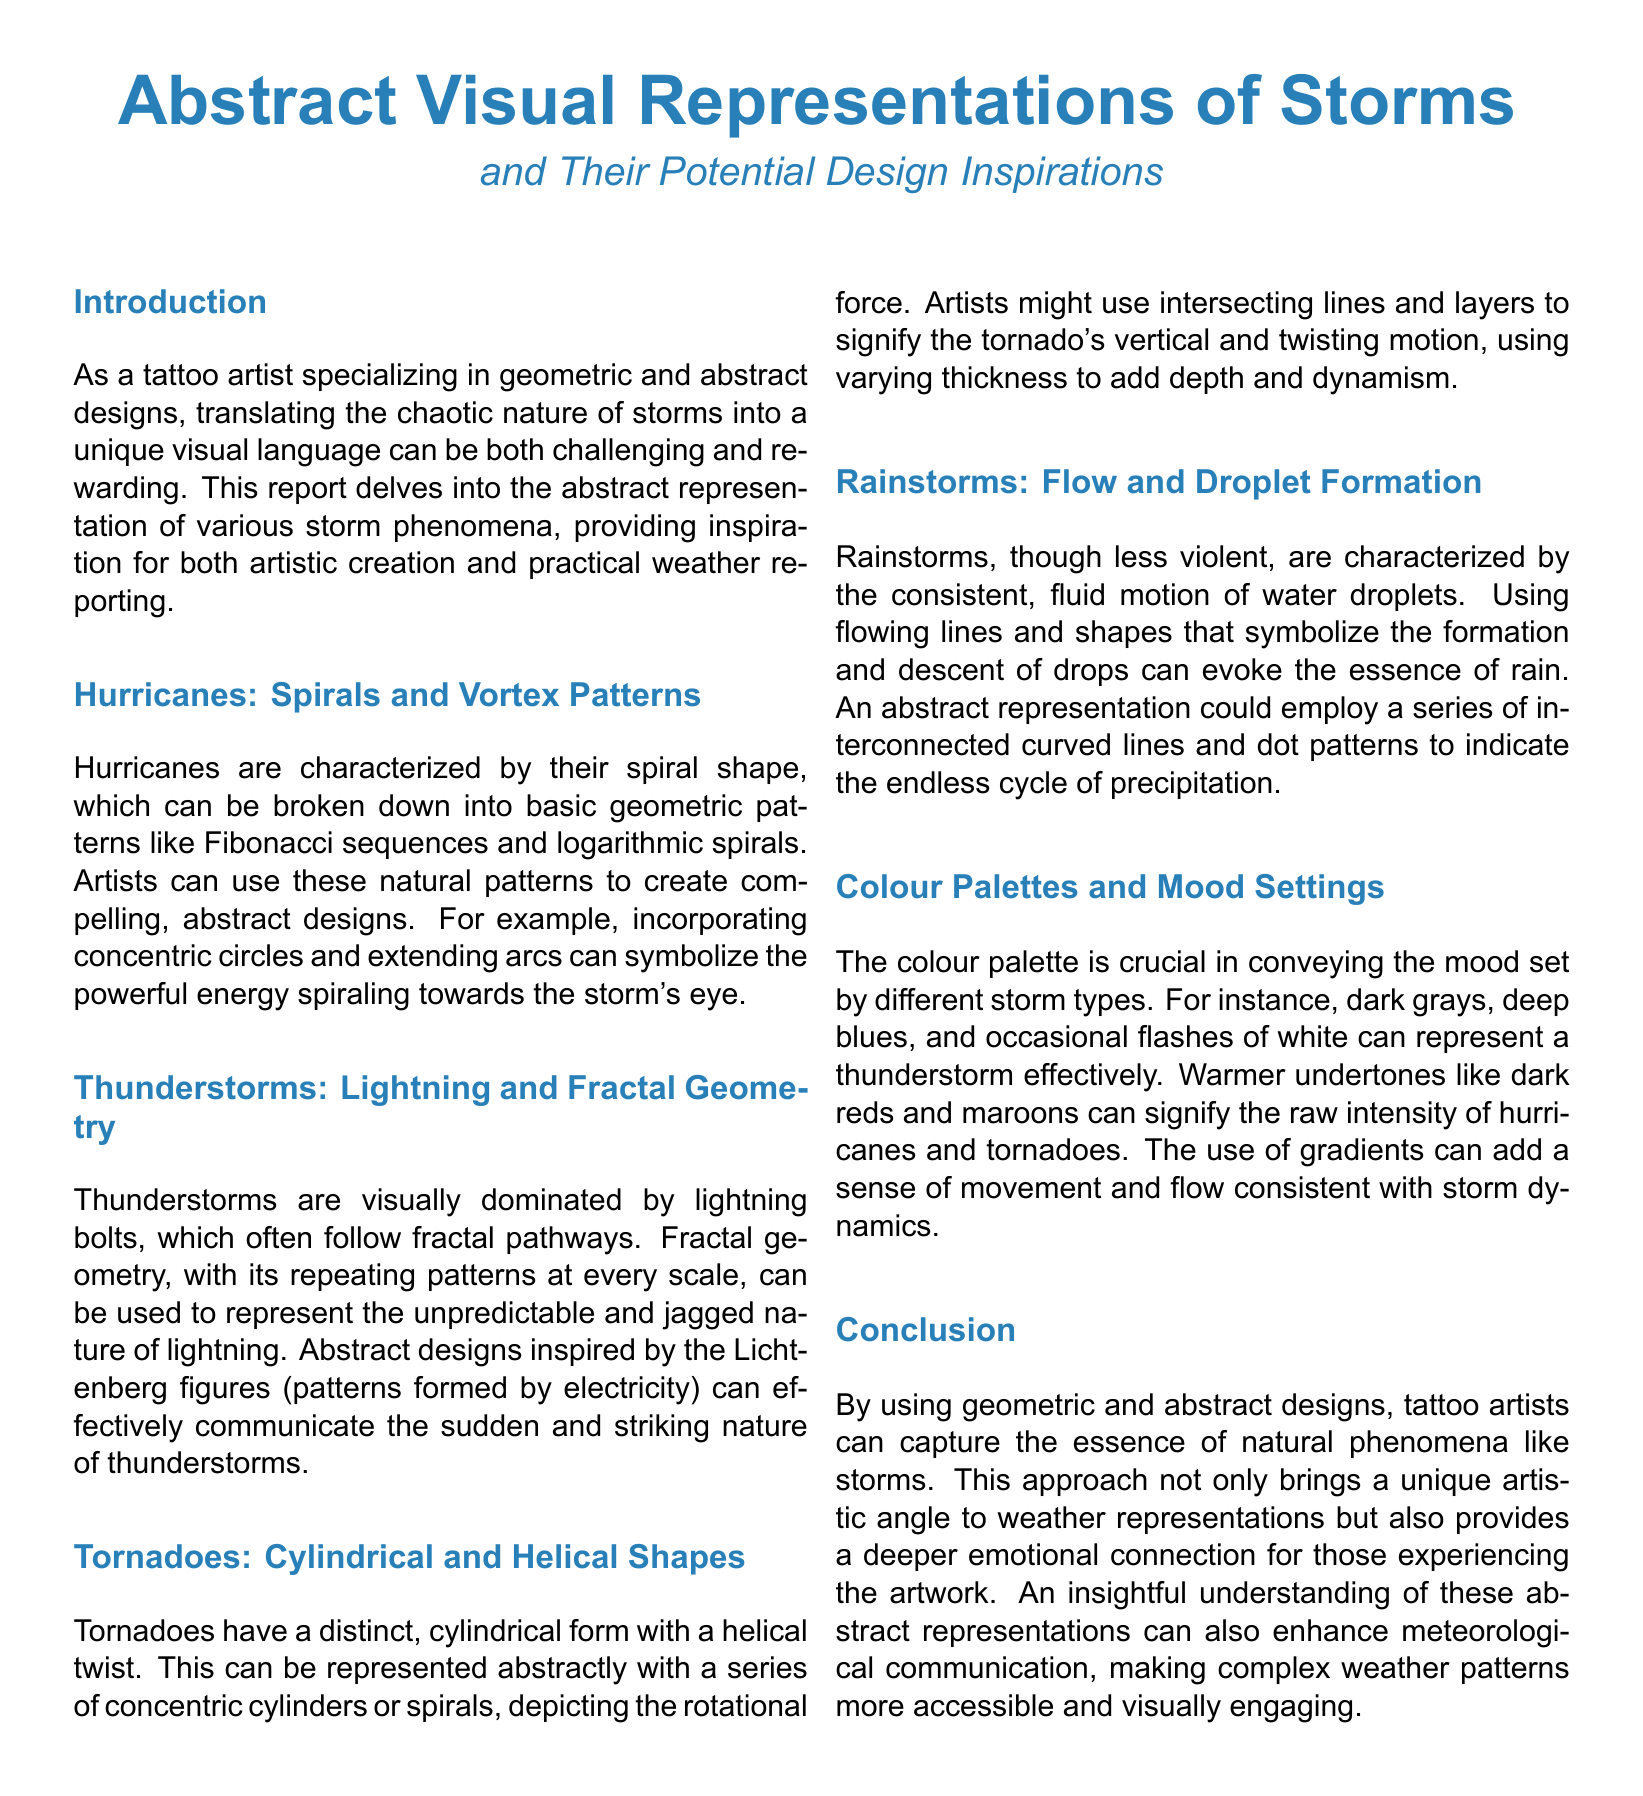What is the main topic of this document? The main topic is the abstract visual representations of storms and their potential design inspirations for tattoo artists.
Answer: Abstract Visual Representations of Storms What color is predominantly associated with thunderstorms? The document describes the mood settings for thunderstorms, including dark grays, deep blues, and white.
Answer: Dark grays What geometric pattern represents hurricanes? The document mentions Fibonacci sequences and logarithmic spirals as geometric patterns related to hurricanes.
Answer: Fibonacci sequences Which storm type is associated with fractal geometry? The section on thunderstorms specifically refers to fractal pathways in the context of lightning.
Answer: Thunderstorms What shapes are used to abstractly represent tornadoes? The document states that tornadoes can be represented with cylindrical and helical shapes.
Answer: Cylindrical and helical shapes What artistic element is used to convey rainstorms' essence? The document highlights flowing lines and shapes to symbolize rainfall.
Answer: Flowing lines How does the document suggest using color gradients? It suggests that gradients can add a sense of movement and flow consistent with storm dynamics.
Answer: Movement and flow What is the conclusion of the report? The conclusion discusses the unique artistic angle of interpreting natural phenomena like storms through geometric and abstract designs.
Answer: Capture the essence of natural phenomena What specific abstract representation can symbolize thunderstorms? The document suggests using Lichtenberg figures to communicate the nature of thunderstorms.
Answer: Lichtenberg figures 